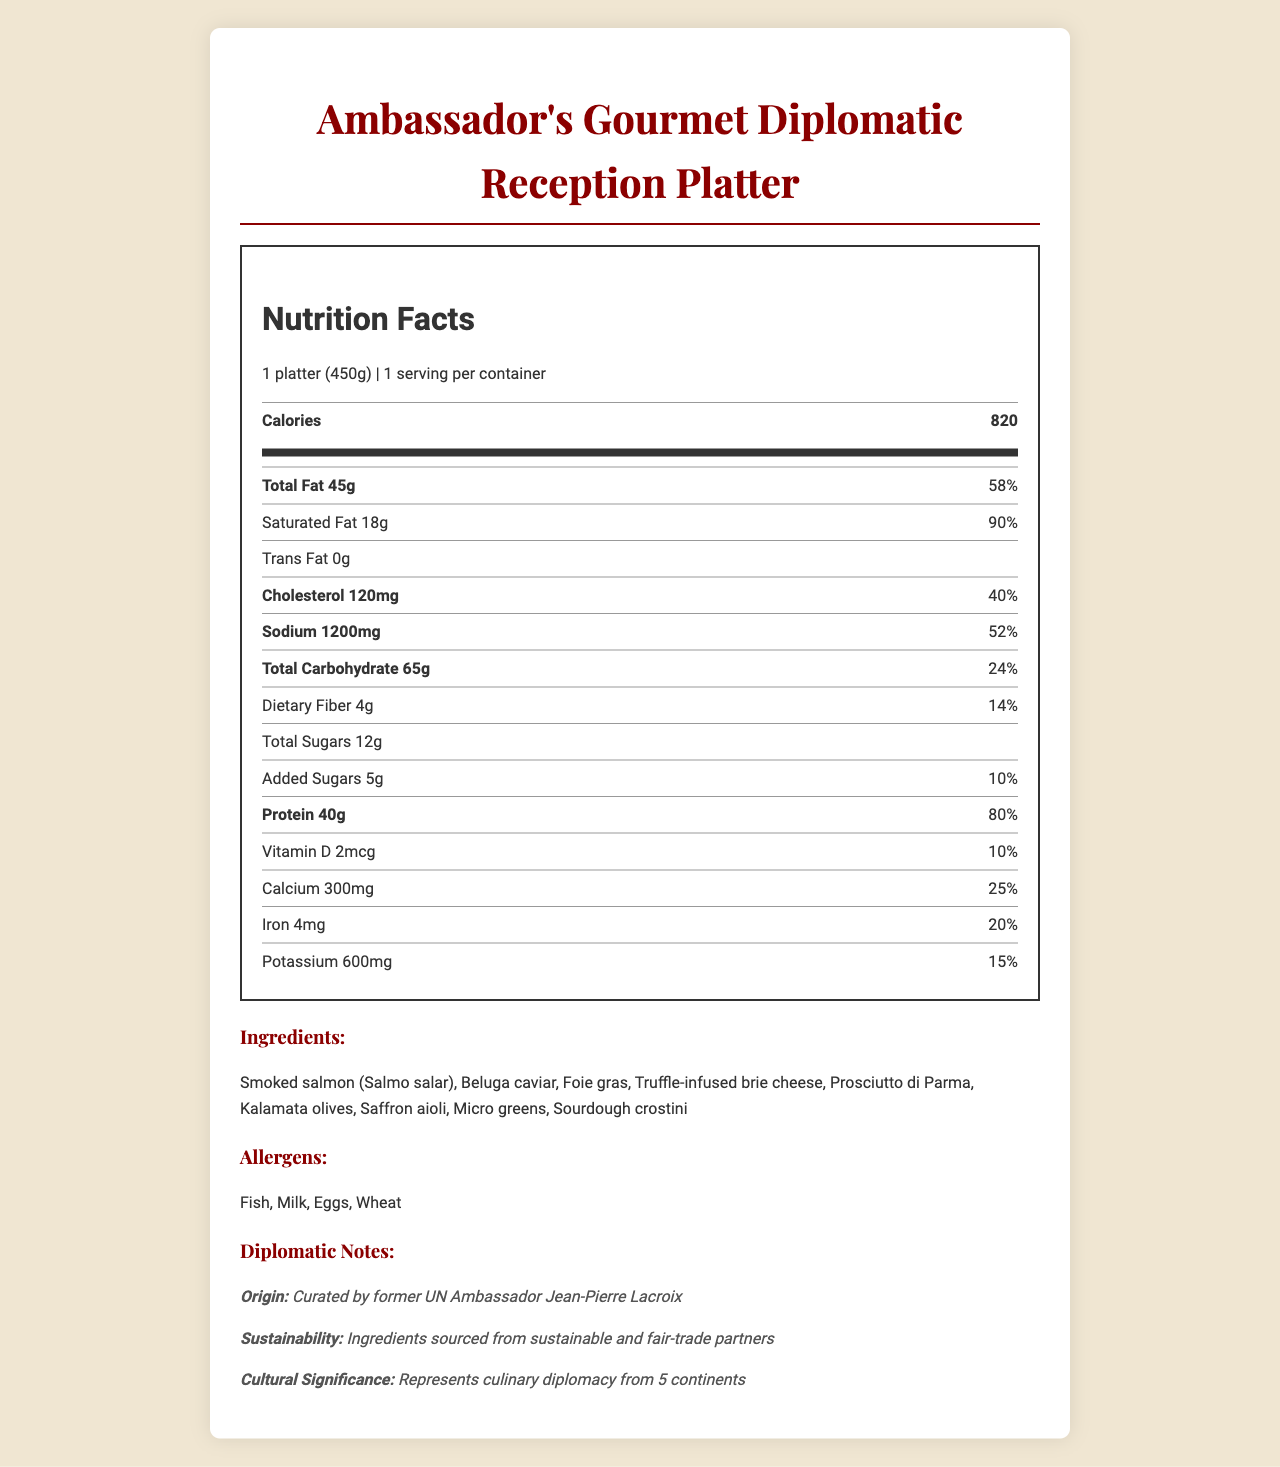What product is this nutrition label for? The document title clearly states the product name at the top.
Answer: Ambassador's Gourmet Diplomatic Reception Platter What is the serving size of this platter? The serving size is mentioned in the initial section under Nutrition Facts.
Answer: 1 platter (450g) How many servings are there in one container? The document specifies "1 serving per container" near the top.
Answer: 1 How many calories are in a serving of the platter? The number of calories is mentioned prominently in the nutrition facts section.
Answer: 820 What percentage of the daily value is the saturated fat content? The saturated fat content and the corresponding daily value percentage are listed together.
Answer: 90% What are the main allergens present in this meal? The allergens are listed under the "Allergens" section in the document.
Answer: Fish, Milk, Eggs, Wheat Which ingredient is not part of the platter? A. Smoked salmon B. Beluga caviar C. Chicken breast D. Prosciutto di Parma "Chicken breast" is not listed in the ingredients section, while the others are.
Answer: C. Chicken breast How much sodium does this platter contain? A. 800mg B. 1000mg C. 1200mg D. 1500mg The sodium content is listed as 1200mg in the nutrition facts section.
Answer: C. 1200mg Does the platter contain any trans fat? The nutrition facts section lists "Trans Fat 0g", indicating there is no trans fat.
Answer: No Is the cholesterol content within the daily recommended limit? The cholesterol content is 120mg, which is 40% of the daily value. Consuming more than 100% per day would exceed recommended limits, so it's relatively high.
Answer: No Summarize the main nutritional insights and additional details of this platter. The summary provides an overview of the key nutritional values, ingredients, and special notes indicated in the document.
Answer: The Ambassador's Gourmet Diplomatic Reception Platter contains 820 calories per serving, with high amounts of total fat (45g, 58% DV), saturated fat (18g, 90% DV), and sodium (1200mg, 52% DV). It has moderate protein content at 40g (80% DV), and includes a variety of gourmet ingredients such as smoked salmon, beluga caviar, and truffle-infused brie cheese. The platter also highlights a global cultural significance and sustainability practices. What is the origin of this gourmet platter? The origin is explicitly mentioned in the "Diplomatic Notes" section.
Answer: Curated by former UN Ambassador Jean-Pierre Lacroix What is the primary cultural significance of the platter? The "Diplomatic Notes" section specifies the cultural significance.
Answer: Represents culinary diplomacy from 5 continents Cannot be answered: How long can this platter be stored before it spoils? The document does not provide any details on storage or spoilage.
Answer: Not enough information 